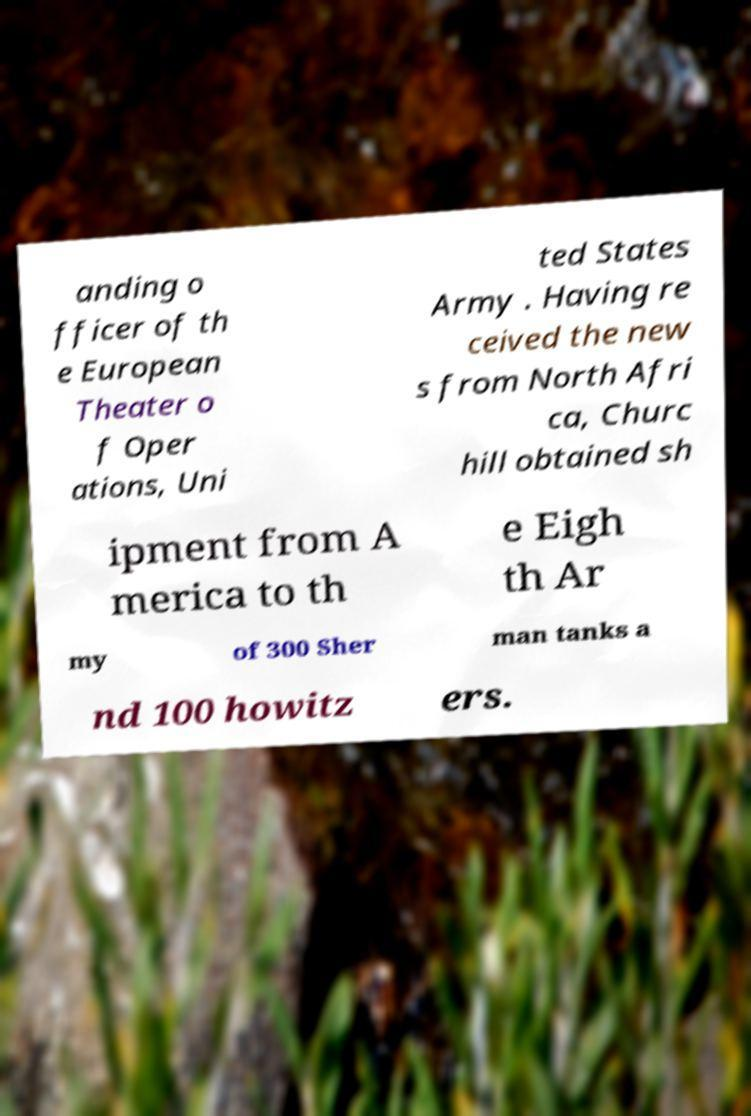There's text embedded in this image that I need extracted. Can you transcribe it verbatim? anding o fficer of th e European Theater o f Oper ations, Uni ted States Army . Having re ceived the new s from North Afri ca, Churc hill obtained sh ipment from A merica to th e Eigh th Ar my of 300 Sher man tanks a nd 100 howitz ers. 